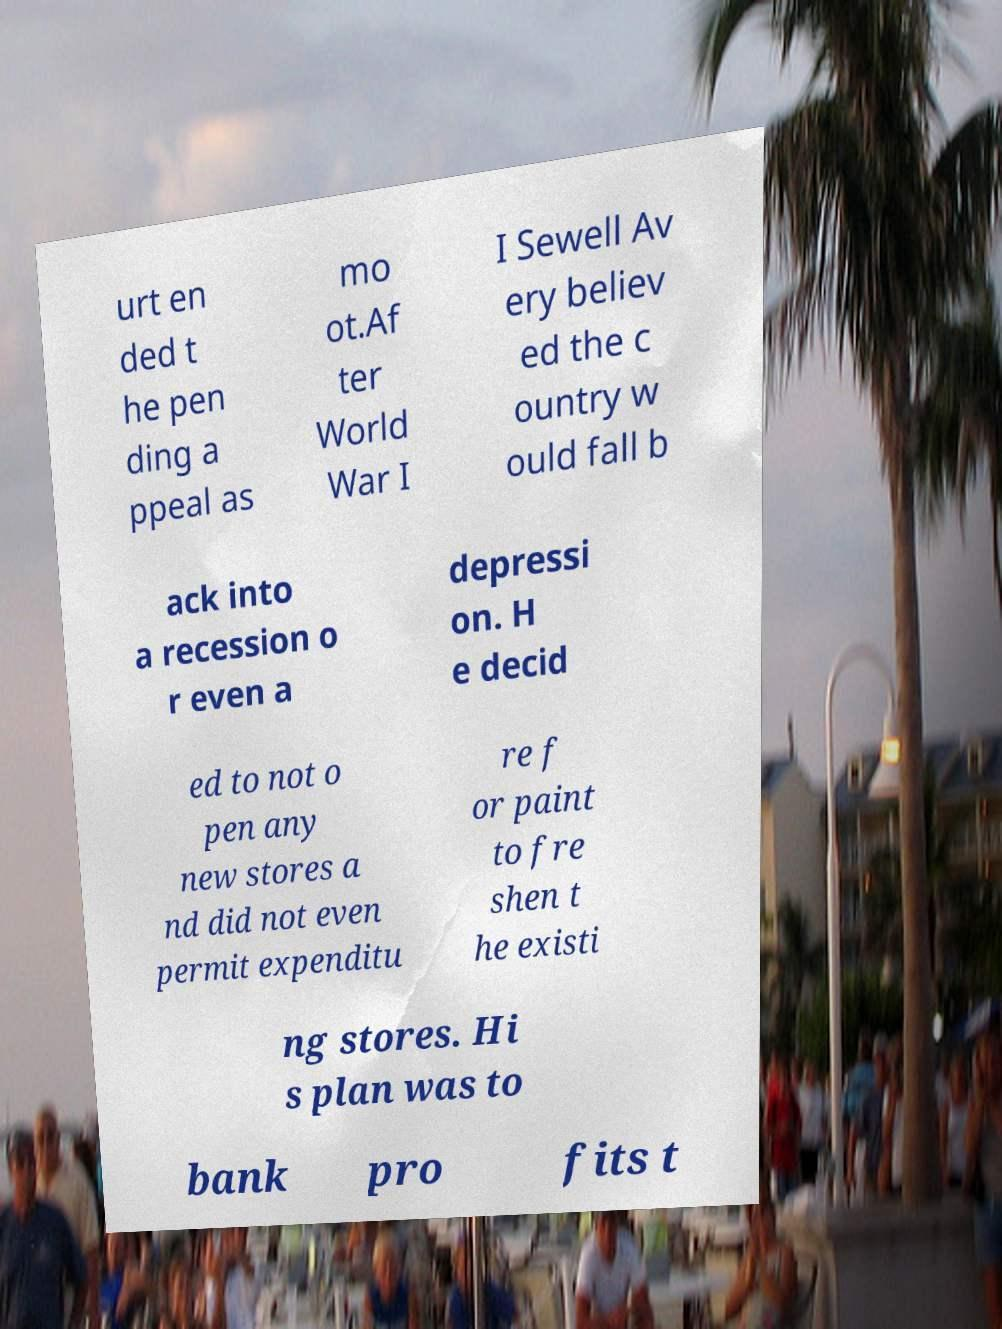Can you accurately transcribe the text from the provided image for me? urt en ded t he pen ding a ppeal as mo ot.Af ter World War I I Sewell Av ery believ ed the c ountry w ould fall b ack into a recession o r even a depressi on. H e decid ed to not o pen any new stores a nd did not even permit expenditu re f or paint to fre shen t he existi ng stores. Hi s plan was to bank pro fits t 